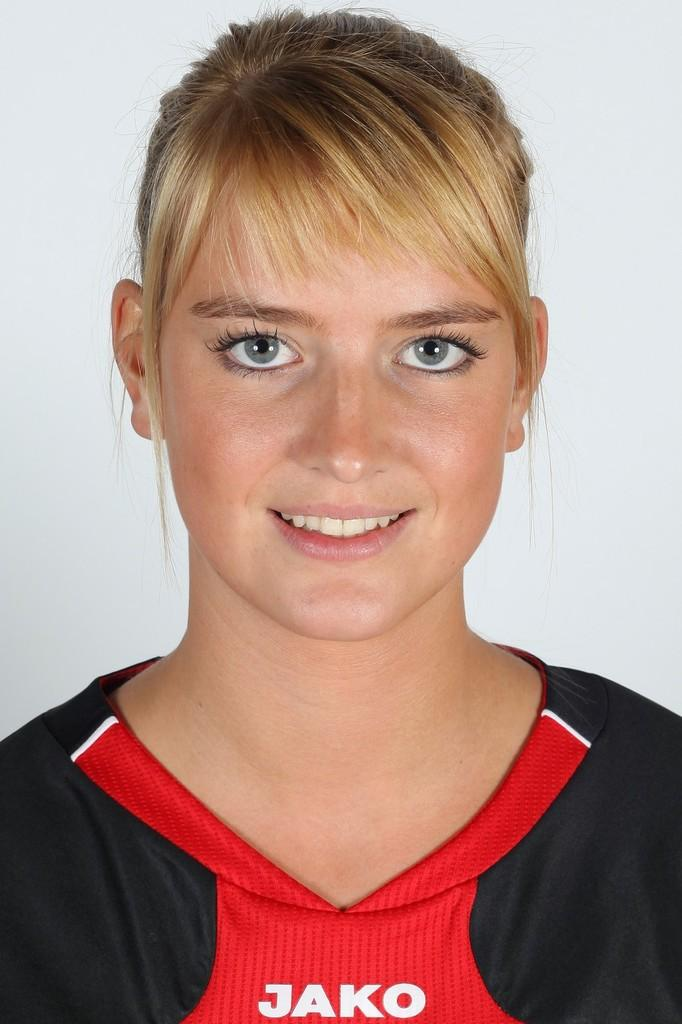Provide a one-sentence caption for the provided image. The woman is staring at the camera and wearing a Jako shirt. 